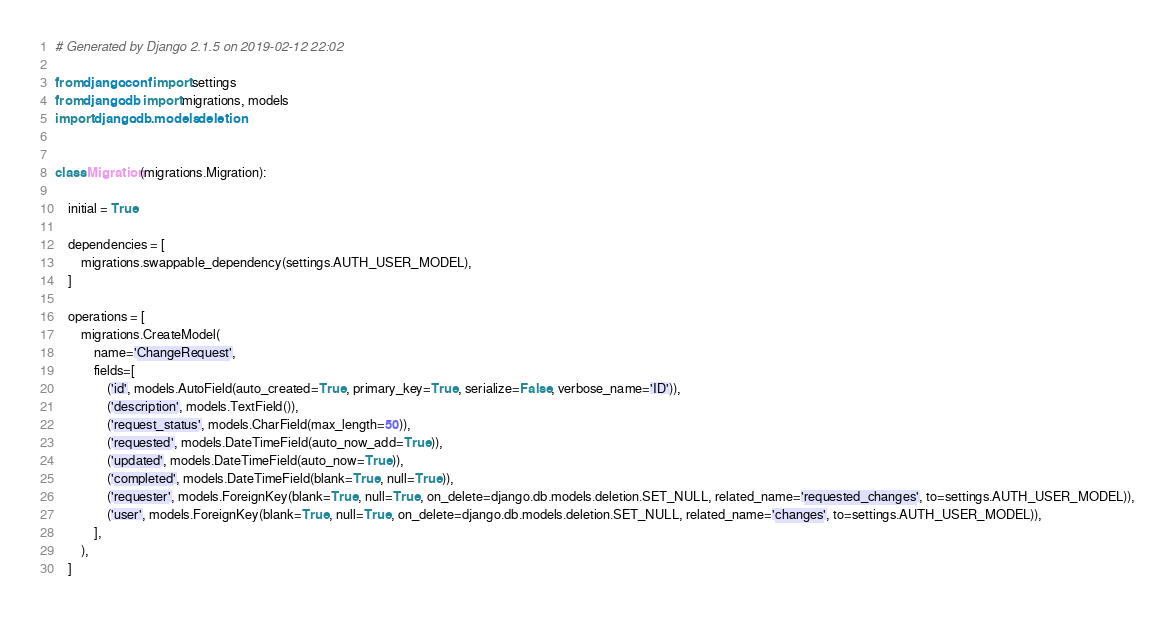Convert code to text. <code><loc_0><loc_0><loc_500><loc_500><_Python_># Generated by Django 2.1.5 on 2019-02-12 22:02

from django.conf import settings
from django.db import migrations, models
import django.db.models.deletion


class Migration(migrations.Migration):

    initial = True

    dependencies = [
        migrations.swappable_dependency(settings.AUTH_USER_MODEL),
    ]

    operations = [
        migrations.CreateModel(
            name='ChangeRequest',
            fields=[
                ('id', models.AutoField(auto_created=True, primary_key=True, serialize=False, verbose_name='ID')),
                ('description', models.TextField()),
                ('request_status', models.CharField(max_length=50)),
                ('requested', models.DateTimeField(auto_now_add=True)),
                ('updated', models.DateTimeField(auto_now=True)),
                ('completed', models.DateTimeField(blank=True, null=True)),
                ('requester', models.ForeignKey(blank=True, null=True, on_delete=django.db.models.deletion.SET_NULL, related_name='requested_changes', to=settings.AUTH_USER_MODEL)),
                ('user', models.ForeignKey(blank=True, null=True, on_delete=django.db.models.deletion.SET_NULL, related_name='changes', to=settings.AUTH_USER_MODEL)),
            ],
        ),
    ]
</code> 